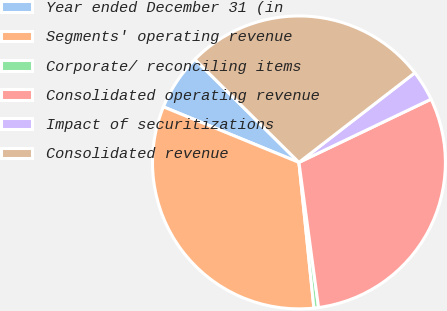Convert chart. <chart><loc_0><loc_0><loc_500><loc_500><pie_chart><fcel>Year ended December 31 (in<fcel>Segments' operating revenue<fcel>Corporate/ reconciling items<fcel>Consolidated operating revenue<fcel>Impact of securitizations<fcel>Consolidated revenue<nl><fcel>6.23%<fcel>32.82%<fcel>0.51%<fcel>29.96%<fcel>3.37%<fcel>27.1%<nl></chart> 